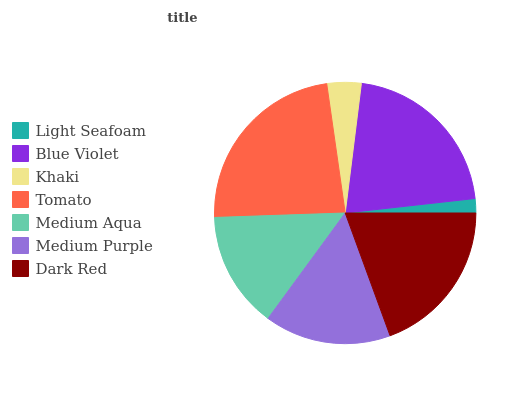Is Light Seafoam the minimum?
Answer yes or no. Yes. Is Tomato the maximum?
Answer yes or no. Yes. Is Blue Violet the minimum?
Answer yes or no. No. Is Blue Violet the maximum?
Answer yes or no. No. Is Blue Violet greater than Light Seafoam?
Answer yes or no. Yes. Is Light Seafoam less than Blue Violet?
Answer yes or no. Yes. Is Light Seafoam greater than Blue Violet?
Answer yes or no. No. Is Blue Violet less than Light Seafoam?
Answer yes or no. No. Is Medium Purple the high median?
Answer yes or no. Yes. Is Medium Purple the low median?
Answer yes or no. Yes. Is Dark Red the high median?
Answer yes or no. No. Is Dark Red the low median?
Answer yes or no. No. 